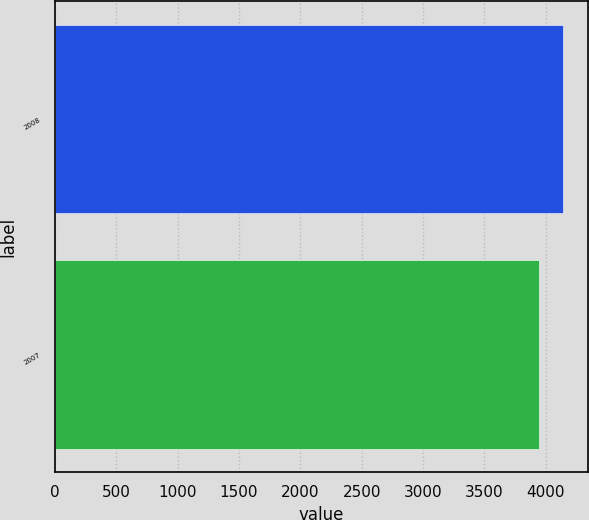Convert chart to OTSL. <chart><loc_0><loc_0><loc_500><loc_500><bar_chart><fcel>2008<fcel>2007<nl><fcel>4139.2<fcel>3944.1<nl></chart> 